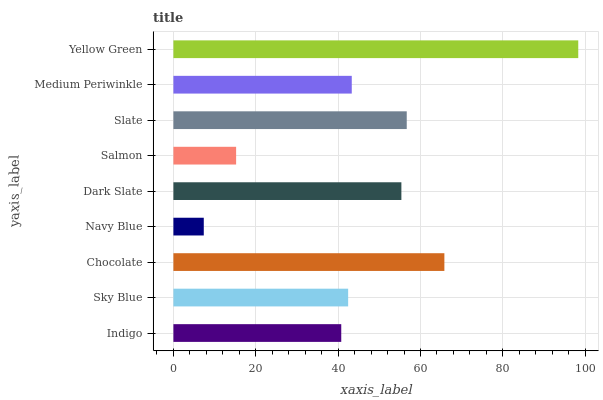Is Navy Blue the minimum?
Answer yes or no. Yes. Is Yellow Green the maximum?
Answer yes or no. Yes. Is Sky Blue the minimum?
Answer yes or no. No. Is Sky Blue the maximum?
Answer yes or no. No. Is Sky Blue greater than Indigo?
Answer yes or no. Yes. Is Indigo less than Sky Blue?
Answer yes or no. Yes. Is Indigo greater than Sky Blue?
Answer yes or no. No. Is Sky Blue less than Indigo?
Answer yes or no. No. Is Medium Periwinkle the high median?
Answer yes or no. Yes. Is Medium Periwinkle the low median?
Answer yes or no. Yes. Is Dark Slate the high median?
Answer yes or no. No. Is Yellow Green the low median?
Answer yes or no. No. 